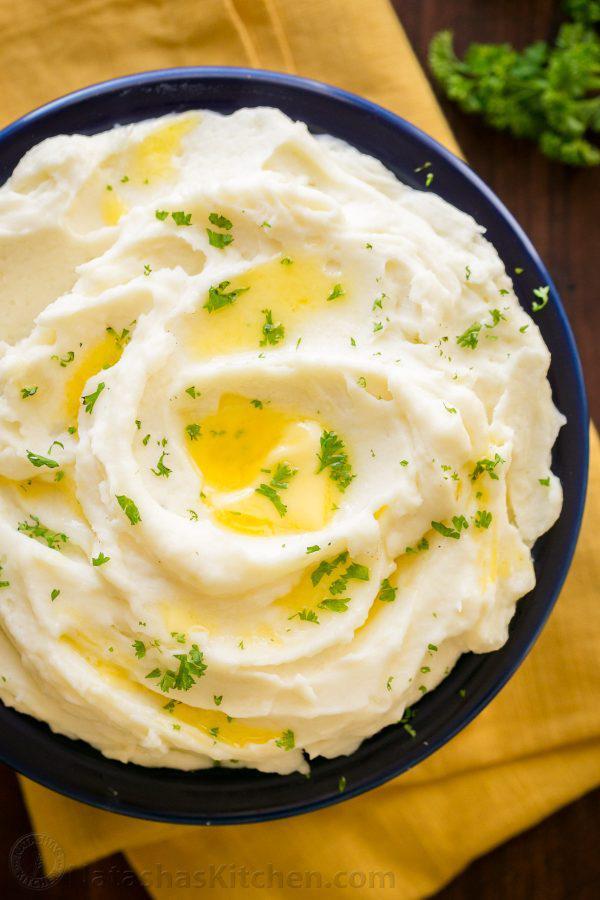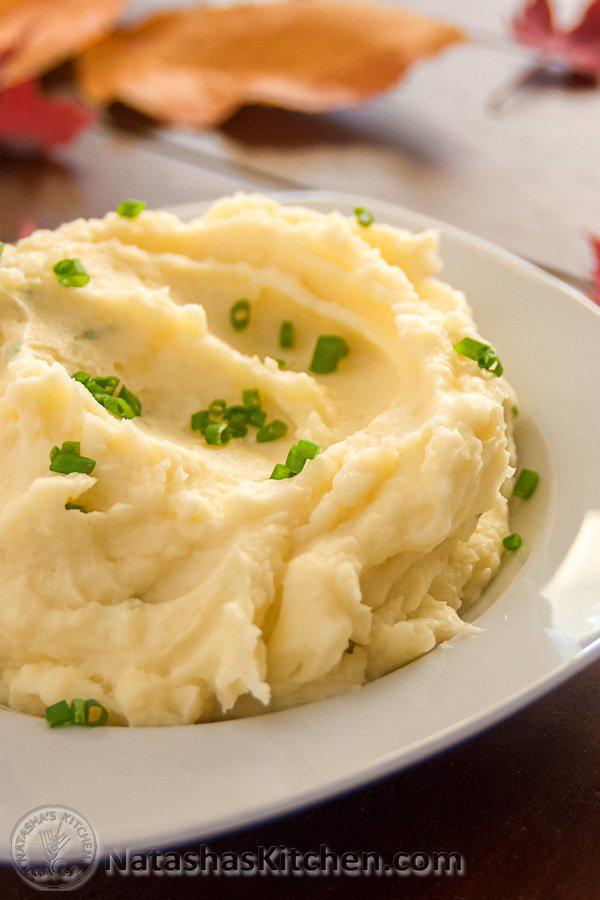The first image is the image on the left, the second image is the image on the right. For the images shown, is this caption "An image shows a bowl of potatoes with handle of a utensil sticking out." true? Answer yes or no. No. 